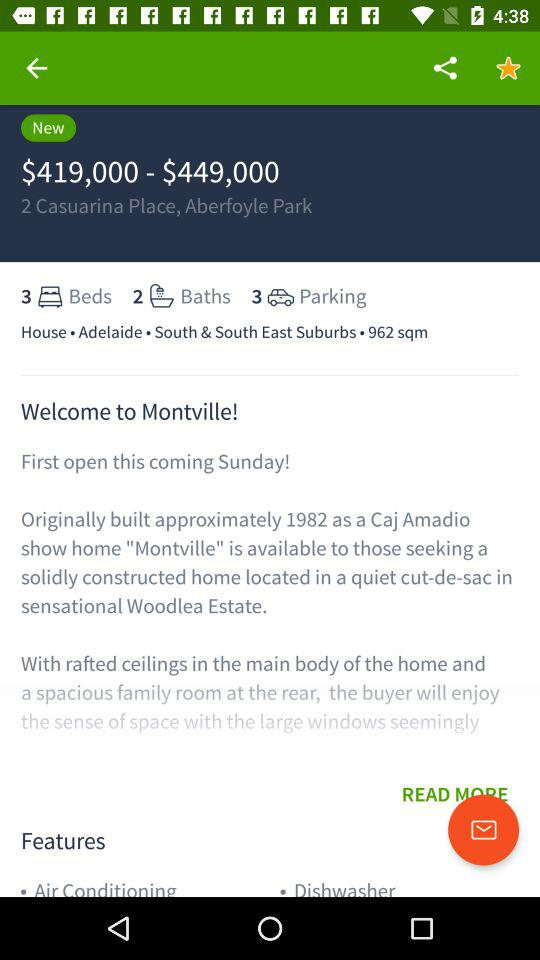What's the location of the house? The location of the house is 2 Casuarina Place, Aberfoyle Park. 